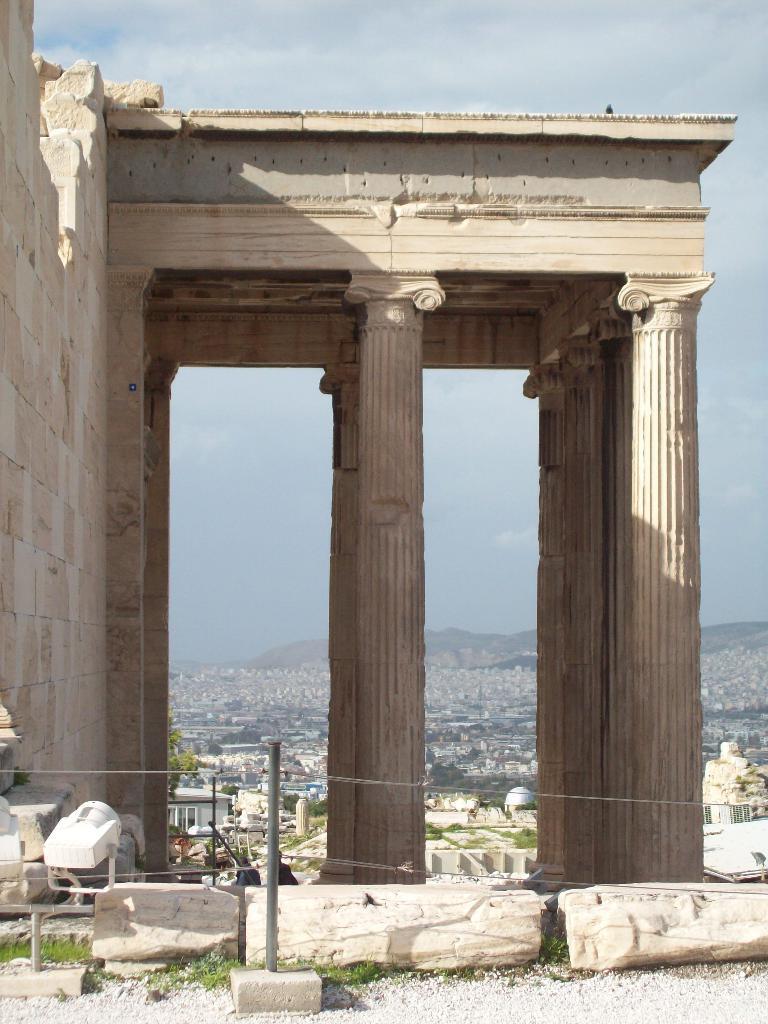Could you give a brief overview of what you see in this image? In this picture I can see there is a fort, it has pillars and there is a wall on the left side. There are rocks and lights on the floor. In the backdrop, there are buildings, trees and the sky is clear. 